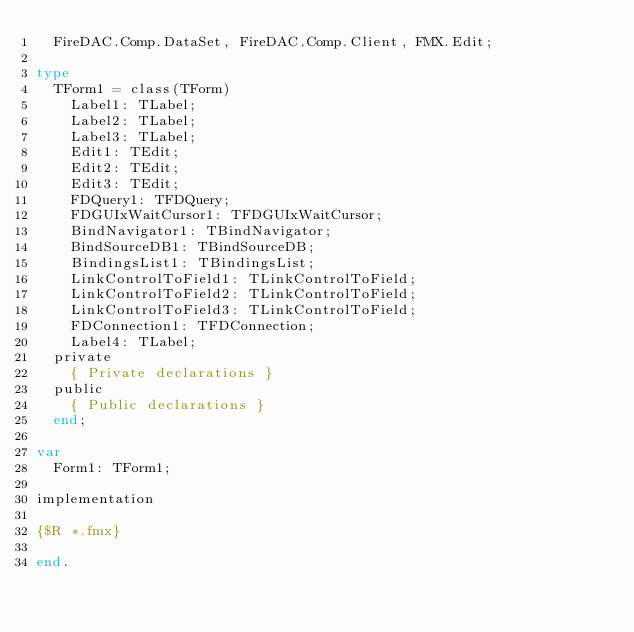<code> <loc_0><loc_0><loc_500><loc_500><_Pascal_>  FireDAC.Comp.DataSet, FireDAC.Comp.Client, FMX.Edit;

type
  TForm1 = class(TForm)
    Label1: TLabel;
    Label2: TLabel;
    Label3: TLabel;
    Edit1: TEdit;
    Edit2: TEdit;
    Edit3: TEdit;
    FDQuery1: TFDQuery;
    FDGUIxWaitCursor1: TFDGUIxWaitCursor;
    BindNavigator1: TBindNavigator;
    BindSourceDB1: TBindSourceDB;
    BindingsList1: TBindingsList;
    LinkControlToField1: TLinkControlToField;
    LinkControlToField2: TLinkControlToField;
    LinkControlToField3: TLinkControlToField;
    FDConnection1: TFDConnection;
    Label4: TLabel;
  private
    { Private declarations }
  public
    { Public declarations }
  end;

var
  Form1: TForm1;

implementation

{$R *.fmx}

end.
</code> 